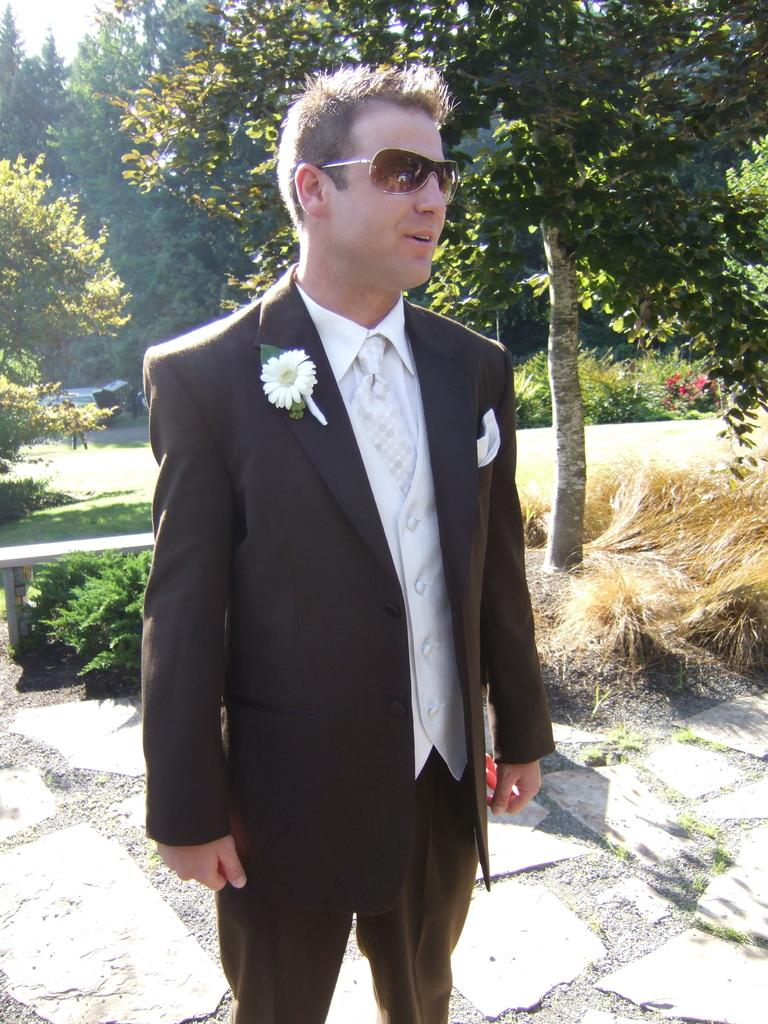Who or what is present in the image? There is a person in the image. What is the person wearing? The person is wearing a coat. What is the person standing on? The person is standing on a surface. What type of vegetation can be seen in the image? There is green grass visible in the image. What other natural elements are present in the image? There are trees in the image. Can you see any coast or wren in the image? No, there is no coast or wren present in the image. Is there a lake visible in the image? No, there is no lake visible in the image. 